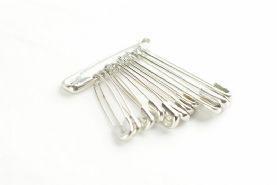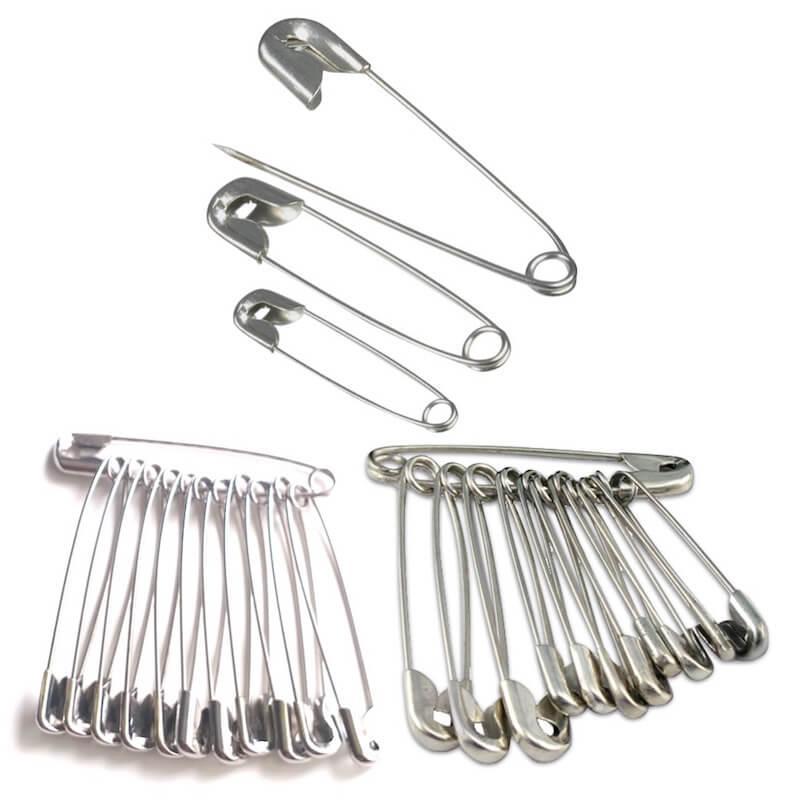The first image is the image on the left, the second image is the image on the right. For the images displayed, is the sentence "There are more pins shown in the image on the left." factually correct? Answer yes or no. No. 